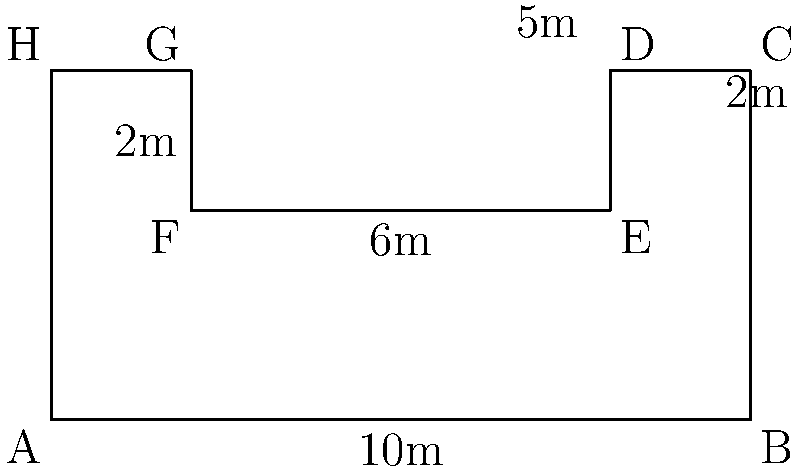As a skilled racer, you're analyzing the new pit stop area at the upcoming Grand Prix. The pit stop area has an irregular shape, as shown in the diagram. Calculate the perimeter of this pit stop area in meters. To find the perimeter of the irregularly shaped pit stop area, we need to sum up the lengths of all sides:

1. Bottom side (AB): 10m
2. Right side (BC): 5m
3. Top-right side (CD): 2m
4. Right vertical side (DE): 2m
5. Middle horizontal side (EF): 6m
6. Left vertical side (FG): 2m
7. Top-left side (GH): 2m
8. Left side (HA): 5m

Now, let's add all these lengths:

$$\text{Perimeter} = 10 + 5 + 2 + 2 + 6 + 2 + 2 + 5 = 34\text{ m}$$

Therefore, the perimeter of the pit stop area is 34 meters.
Answer: 34 m 